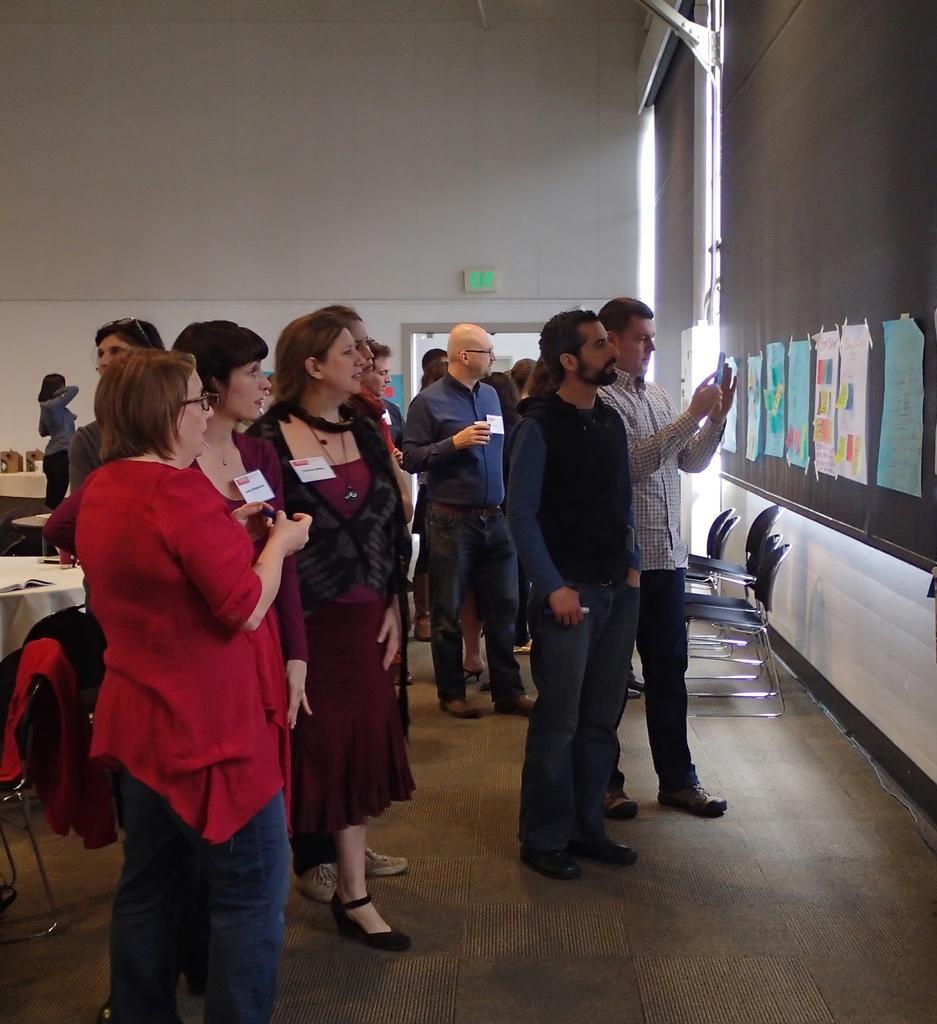Describe this image in one or two sentences. In this picture we can see a group of people standing on the floor. A man is holding an object. On the left side of the image, there is a table and there is a jacket on the chair. On the right side of the image, there are chairs and there are some papers attached to a black object. Behind the people, there is a signboard and a wall. 